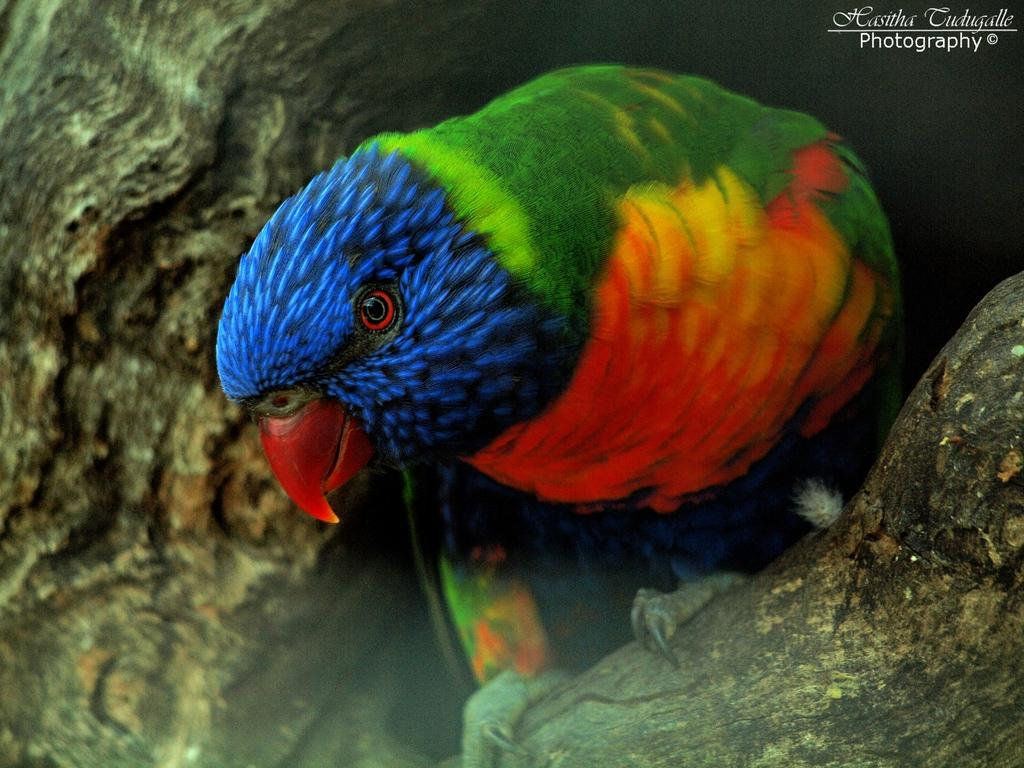What type of animal is in the picture? There is a parrot in the picture. What is the background of the picture? There is tree bark in the picture. Where is the text located in the picture? The text is at the top right corner of the picture. What type of door can be seen in the picture? There is no door present in the picture; it features a parrot and tree bark. Can you tell me what the father of the parrot is doing in the picture? There is no father or any human figure present in the picture; it only features a parrot and tree bark. 